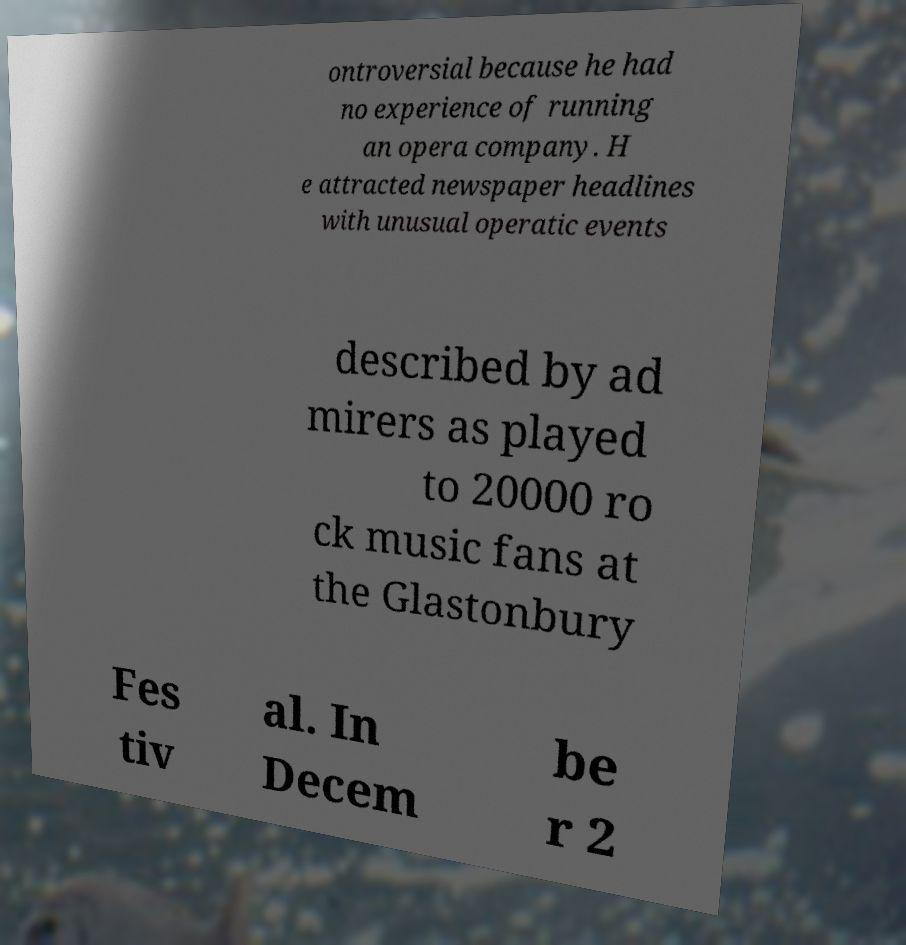Can you accurately transcribe the text from the provided image for me? ontroversial because he had no experience of running an opera company. H e attracted newspaper headlines with unusual operatic events described by ad mirers as played to 20000 ro ck music fans at the Glastonbury Fes tiv al. In Decem be r 2 